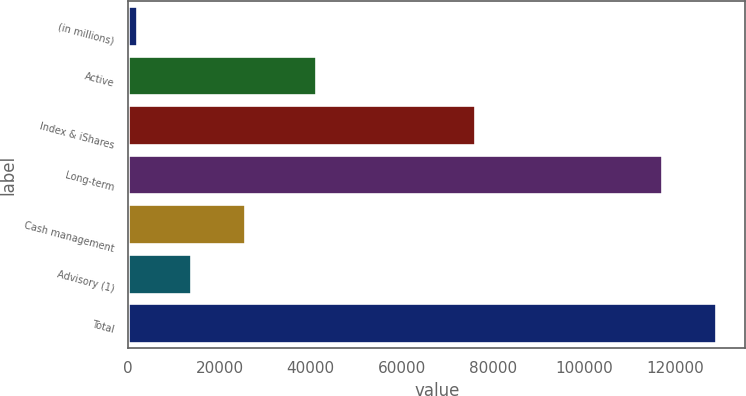<chart> <loc_0><loc_0><loc_500><loc_500><bar_chart><fcel>(in millions)<fcel>Active<fcel>Index & iShares<fcel>Long-term<fcel>Cash management<fcel>Advisory (1)<fcel>Total<nl><fcel>2013<fcel>41177<fcel>75936<fcel>117113<fcel>25555.8<fcel>13784.4<fcel>128884<nl></chart> 